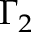<formula> <loc_0><loc_0><loc_500><loc_500>\Gamma _ { 2 }</formula> 